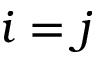<formula> <loc_0><loc_0><loc_500><loc_500>i = j</formula> 